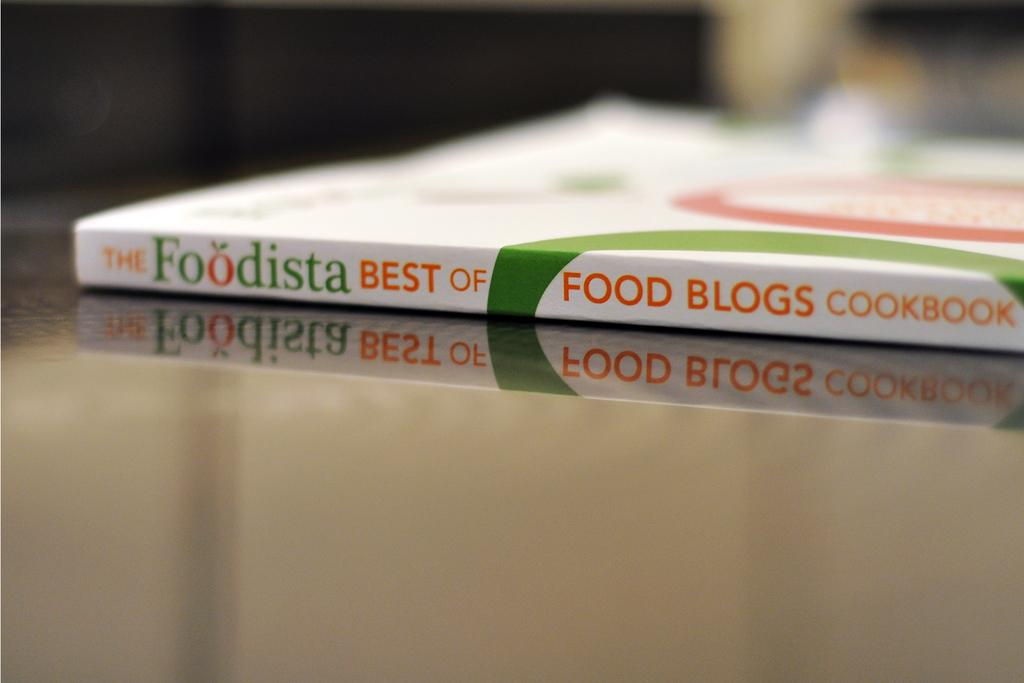Provide a one-sentence caption for the provided image. A Best of Food Blogs cookbook sits on a countertop. 